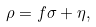Convert formula to latex. <formula><loc_0><loc_0><loc_500><loc_500>\rho = f \sigma + \eta ,</formula> 